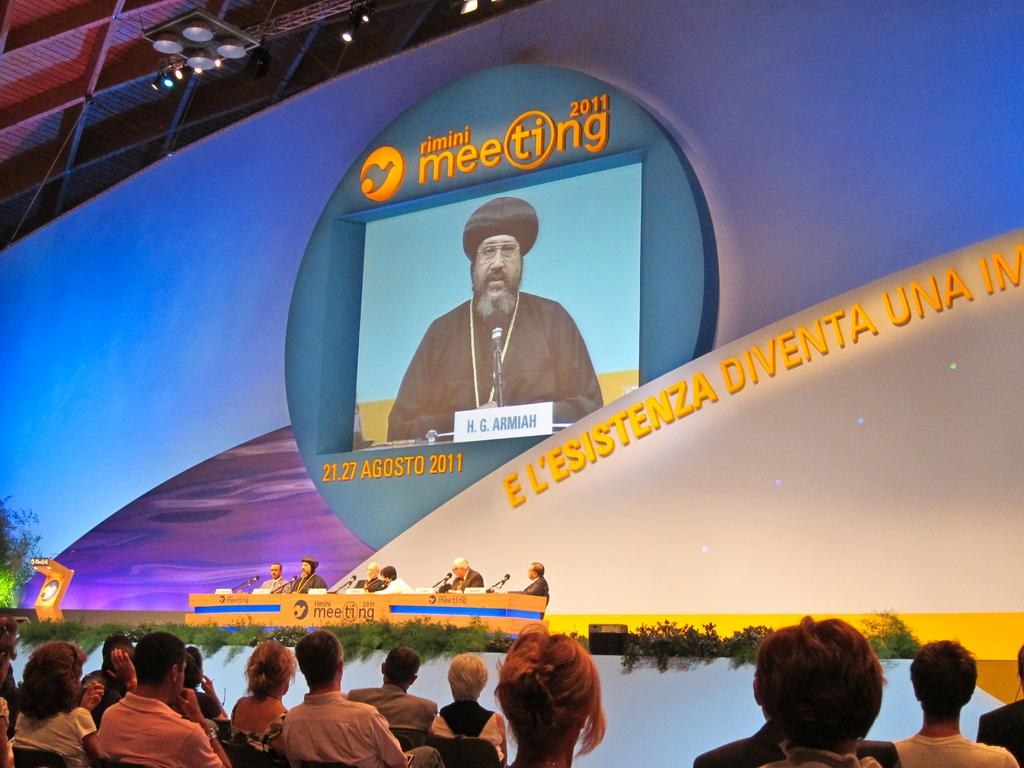<image>
Give a short and clear explanation of the subsequent image. A an audience with people sitting at a table on a stage for the Rimini Meeting 2011. 